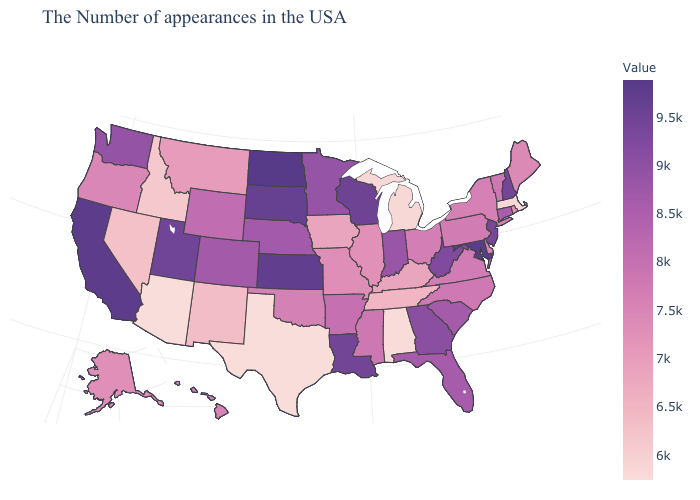Which states have the lowest value in the USA?
Write a very short answer. Texas. Among the states that border Connecticut , which have the lowest value?
Give a very brief answer. Massachusetts. Among the states that border Wisconsin , which have the lowest value?
Write a very short answer. Michigan. Which states hav the highest value in the South?
Answer briefly. Maryland. Is the legend a continuous bar?
Answer briefly. Yes. Is the legend a continuous bar?
Give a very brief answer. Yes. Does North Dakota have the highest value in the USA?
Concise answer only. Yes. Does the map have missing data?
Write a very short answer. No. Among the states that border Colorado , which have the lowest value?
Write a very short answer. Arizona. 